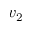<formula> <loc_0><loc_0><loc_500><loc_500>v _ { 2 }</formula> 